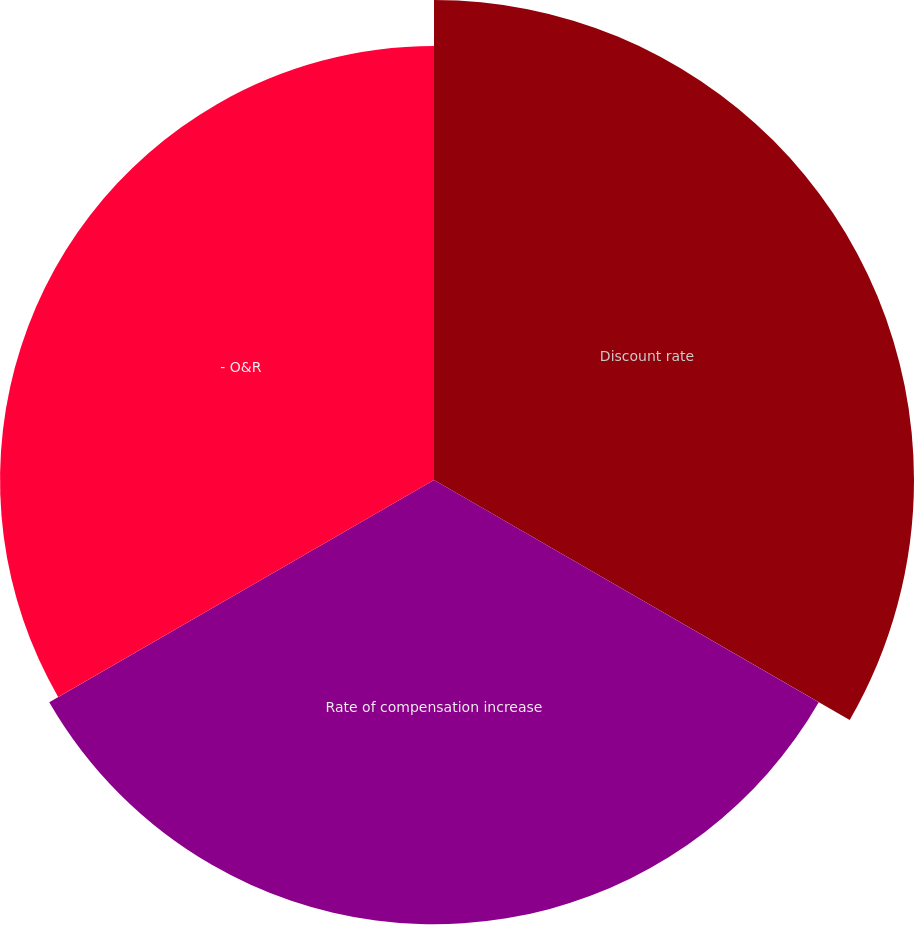<chart> <loc_0><loc_0><loc_500><loc_500><pie_chart><fcel>Discount rate<fcel>Rate of compensation increase<fcel>- O&R<nl><fcel>35.34%<fcel>32.71%<fcel>31.95%<nl></chart> 